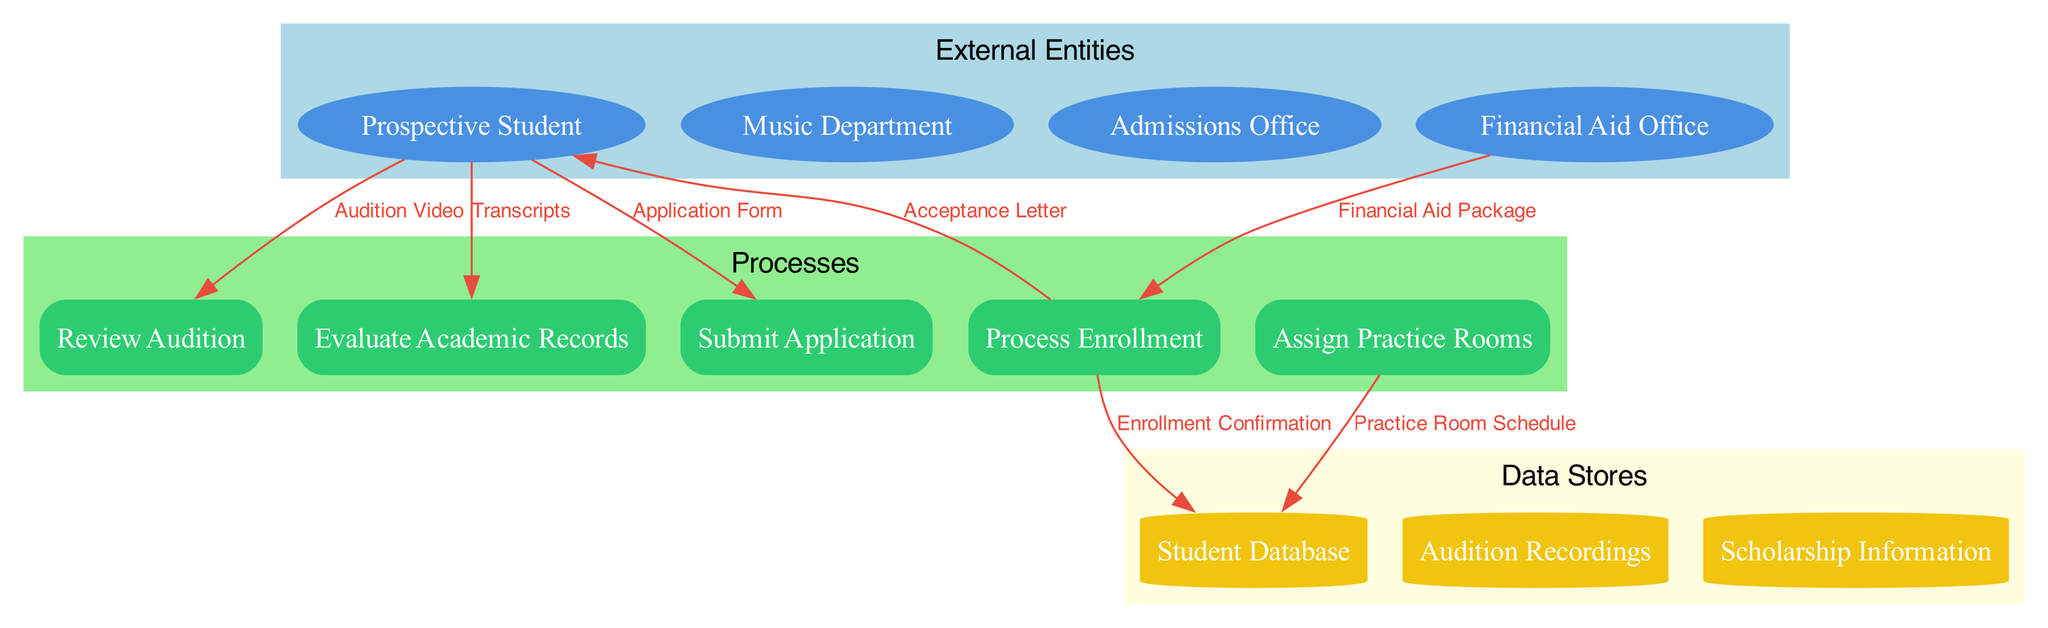What is the total number of external entities in the diagram? The diagram lists four external entities: Prospective Student, Music Department, Admissions Office, and Financial Aid Office. Counting these yields a total of 4 external entities.
Answer: 4 Which process does the 'Application Form' flow into? The 'Application Form' flows from the Prospective Student to the Submit Application process. This is shown by the directed edge connecting these two nodes with 'Application Form'.
Answer: Submit Application How many data stores are represented in the diagram? The diagram includes three data stores: Student Database, Audition Recordings, and Scholarship Information. Therefore, the total count is 3 data stores.
Answer: 3 What is the relationship of 'Financial Aid Package' in the diagram? 'Financial Aid Package' originates from the Financial Aid Office and flows into the Process Enrollment. This shows that the package is relevant to the enrollment process.
Answer: Process Enrollment Which data flow comes from the Process Enrollment process? The data flow 'Acceptance Letter' originates from the Process Enrollment process and goes to the Prospective Student. This indicates that once a student is enrolled, they receive this letter.
Answer: Acceptance Letter What is the purpose of the 'Assign Practice Rooms' process? The 'Assign Practice Rooms' process uses the data flow 'Practice Room Schedule' to connect to the Student Database. This means its purpose is to manage and assign practice rooms to students.
Answer: Manage practice rooms Identify the first process that a Prospective Student interacts with in the diagram. The first process the Prospective Student interacts with is the Submit Application process, as indicated by the flow of the Application Form.
Answer: Submit Application What data flows directly into the 'Review Audition' process? The 'Audition Video' flows directly into the Review Audition process, which indicates that this is the required documentation for the audition review.
Answer: Audition Video What does the 'Enrollment Confirmation' flow to? The 'Enrollment Confirmation' flows from the Process Enrollment to the Student Database, signifying that the confirmed enrollment information is saved in the database.
Answer: Student Database 